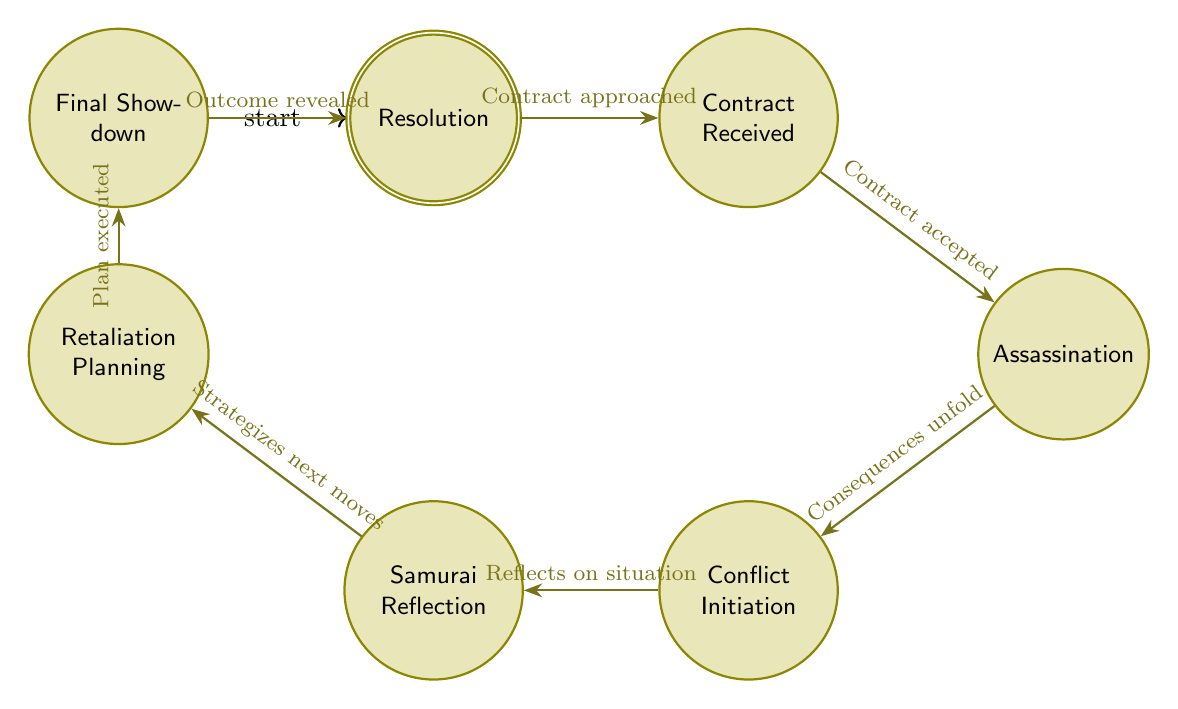What is the initial state in the diagram? The initial state is labeled "Start," which indicates where the story begins and introduces the protagonist.
Answer: Start How many states are present in the diagram? The diagram features a total of 8 states, each representing different phases in the narrative.
Answer: 8 What follows after "Assassination"? The state that follows "Assassination" is "Conflict Initiation," indicating the escalation of events after the assassination is carried out.
Answer: Conflict Initiation Which state involves Ghost Dog reflecting on his actions? The state where Ghost Dog reflects on his actions is called "Samurai Reflection," where he considers his situation through the lens of Samurai philosophy.
Answer: Samurai Reflection What is the transition from "Retaliation Planning" to "Final Showdown"? The transition is described as "Plan executed," indicating that the strategies formulated in the previous state are put into action.
Answer: Plan executed What is the last state in the diagram? The last state, or accepting state, is "Resolution," which indicates the conclusion of the storyline showing the outcome after the final confrontation.
Answer: Resolution What state comes immediately after "Contract Received"? The state that comes immediately after "Contract Received" is "Assassination," which signifies that Ghost Dog has accepted the contract and is proceeding with the mission.
Answer: Assassination Which state signifies the beginning of conflict? The state that signifies the beginning of conflict is "Conflict Initiation," which is triggered after the assassination outcome begins to unfold and the Mafia learns Ghost Dog's identity.
Answer: Conflict Initiation In how many transitions does "Samurai Reflection" participate? "Samurai Reflection" participates in 2 transitions: one leading to "Retaliation Planning" and the other coming from "Conflict Initiation."
Answer: 2 